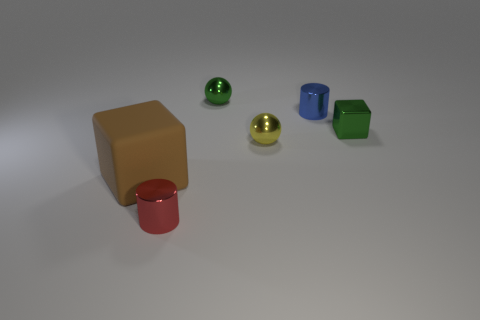Add 3 small blue metal spheres. How many objects exist? 9 Subtract all green balls. How many balls are left? 1 Subtract all spheres. How many objects are left? 4 Subtract all small yellow things. Subtract all tiny cyan matte cylinders. How many objects are left? 5 Add 1 tiny cubes. How many tiny cubes are left? 2 Add 5 large brown rubber things. How many large brown rubber things exist? 6 Subtract 0 red spheres. How many objects are left? 6 Subtract all purple blocks. Subtract all purple cylinders. How many blocks are left? 2 